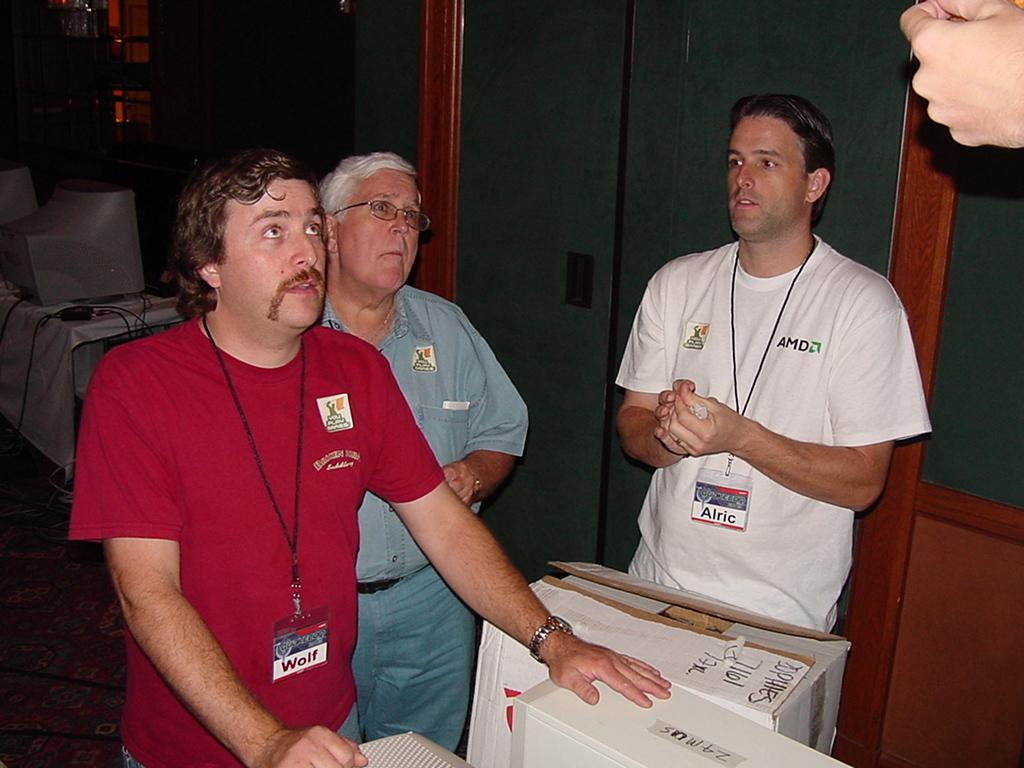What can be seen in the image involving people? There are people standing in the image. What is the cardboard box used for in the image? The cardboard box is not used for anything specific in the image, but it is present. What is the location of the objects in the image? The objects are on a table in the image. What type of door is visible on the right side of the image? There is a glass door on the right side of the image. Can you tell me how many times the people in the image have received approval for their actions? There is no information about approval or actions of the people in the image, so it cannot be determined. 